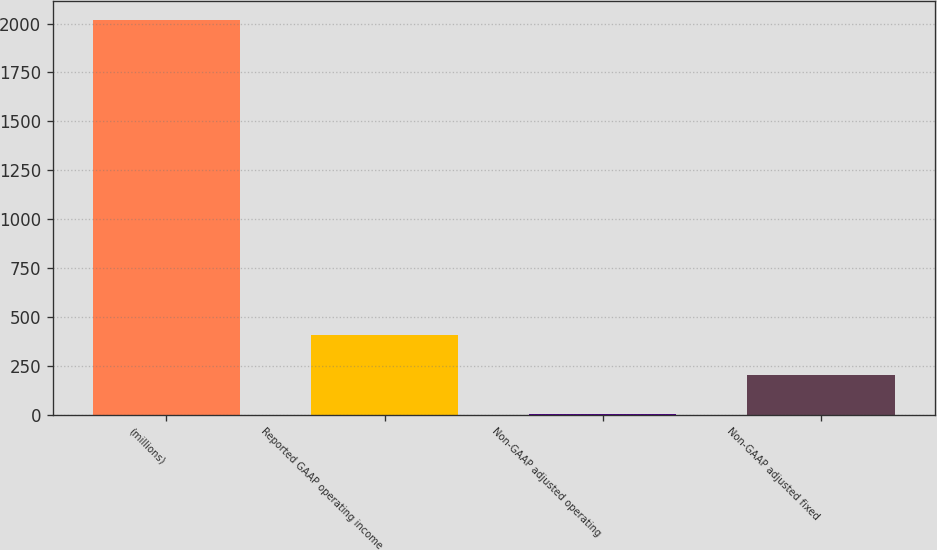Convert chart to OTSL. <chart><loc_0><loc_0><loc_500><loc_500><bar_chart><fcel>(millions)<fcel>Reported GAAP operating income<fcel>Non-GAAP adjusted operating<fcel>Non-GAAP adjusted fixed<nl><fcel>2016<fcel>404.8<fcel>2<fcel>203.4<nl></chart> 